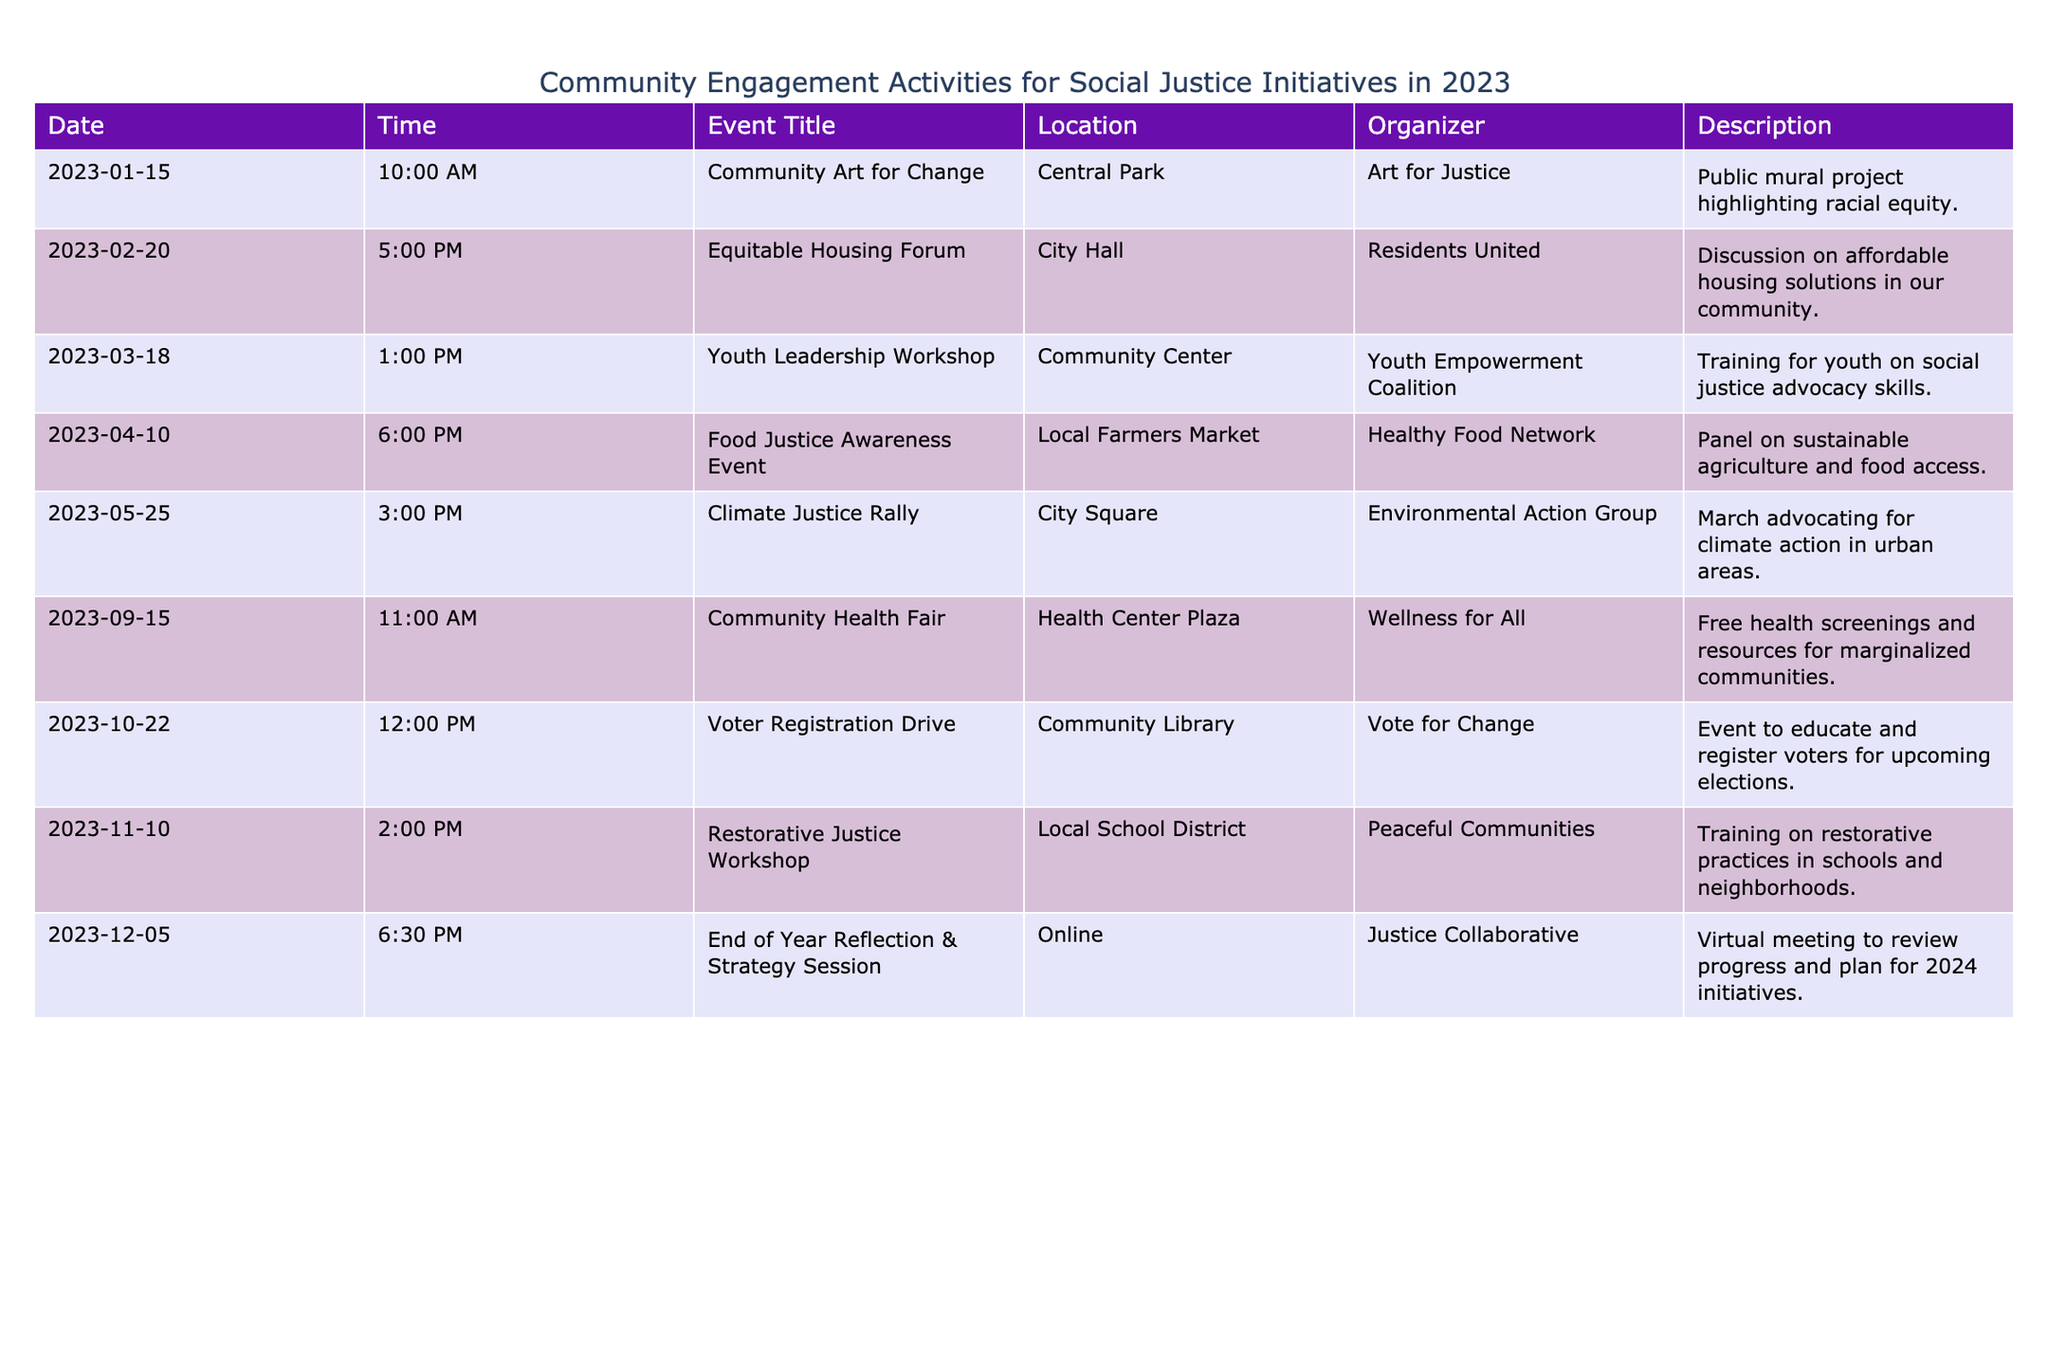What is the location of the Community Art for Change event? The table lists the Community Art for Change event under the "Location" column as Central Park.
Answer: Central Park Which organization is responsible for the Food Justice Awareness Event? By reviewing the "Organizer" column, the organization for the Food Justice Awareness Event is Healthy Food Network.
Answer: Healthy Food Network How many events are scheduled for the month of October? There is one entry with a date in October, which is the Voter Registration Drive on October 22.
Answer: 1 Is there an event focusing on youth leadership? The table shows an event titled Youth Leadership Workshop, which indicates that there is indeed a focus on youth leadership.
Answer: Yes What is the purpose of the End of Year Reflection & Strategy Session? The description for this event states that it is a virtual meeting to review progress and plan for 2024 initiatives, showing its purpose is reflective and strategic.
Answer: To review progress and plan for 2024 initiatives What is the time difference between the Climate Justice Rally and the Voter Registration Drive? The Climate Justice Rally is on May 25 at 3:00 PM and the Voter Registration Drive is on October 22 at 12:00 PM. To compute the difference, we consider the number of days between May 25 and October 22, which is 120 days. Thus, the time difference is 120 days.
Answer: 120 days How many different locations are involved in these events? By scanning the "Location" column, we identify the different venues: Central Park, City Hall, Community Center, Local Farmers Market, City Square, Health Center Plaza, Community Library, Local School District, and Online, resulting in a total of 9 different locations.
Answer: 9 What types of events are scheduled in the second half of the year? Reviewing the events from July to December, they are the Community Health Fair (September 15), Voter Registration Drive (October 22), Restorative Justice Workshop (November 10), and End of Year Reflection & Strategy Session (December 5). These events cover health, education, and justice themes.
Answer: Health, education, and justice themes 